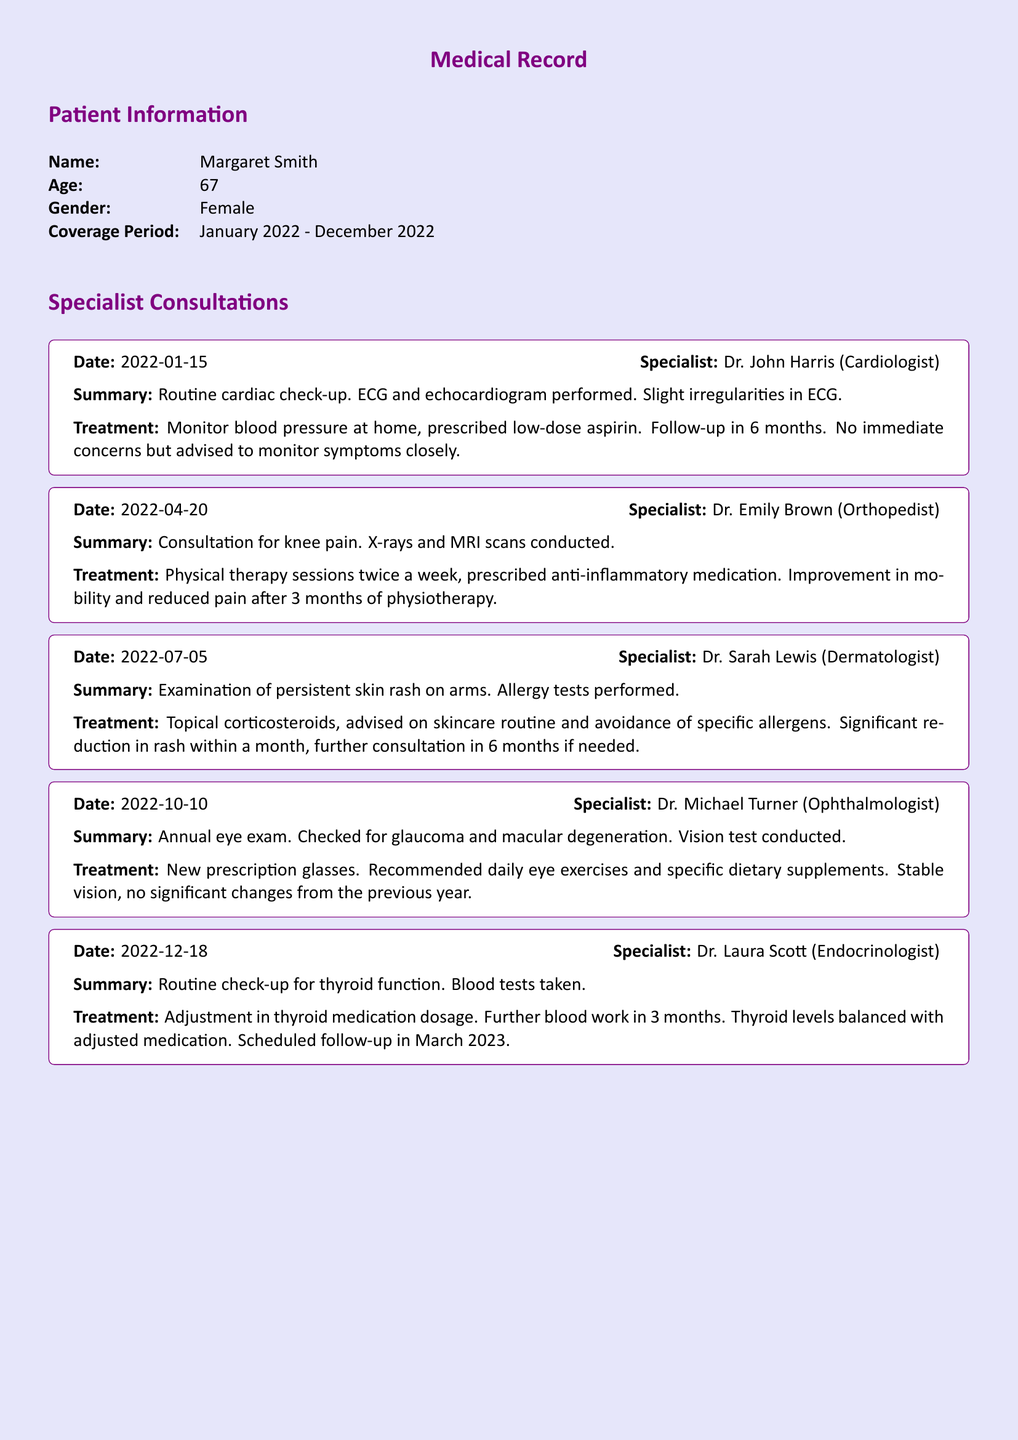What was the first consultation date? The first consultation took place on January 15, 2022, as stated in the document.
Answer: January 15, 2022 Who was the cardiologist? The document lists Dr. John Harris as the cardiologist for the first consultation.
Answer: Dr. John Harris What treatment was prescribed for knee pain? The recommended treatment for knee pain included physical therapy sessions and anti-inflammatory medication.
Answer: Physical therapy sessions twice a week, anti-inflammatory medication When was the annual eye exam conducted? The annual eye exam was performed on October 10, 2022, according to the summary.
Answer: October 10, 2022 How many months until the follow-up for thyroid function? The follow-up for thyroid function is scheduled in 3 months after the last consultation, which is noted in the document.
Answer: 3 months What improvement was noted after physiotherapy? The document states there was an improvement in mobility and reduced pain post physiotherapy sessions.
Answer: Improvement in mobility and reduced pain What medication was adjusted during the endocrinologist consultation? The endocrinologist consultation involved an adjustment in thyroid medication dosage as recorded.
Answer: Thyroid medication dosage Which specialist performed allergy tests? Allergy tests were performed by the dermatologist during the consultation regarding the skin rash.
Answer: Dr. Sarah Lewis What was the outcome of the vision test? The outcome of the vision test indicated stable vision with no significant changes from the previous year.
Answer: Stable vision, no significant changes 